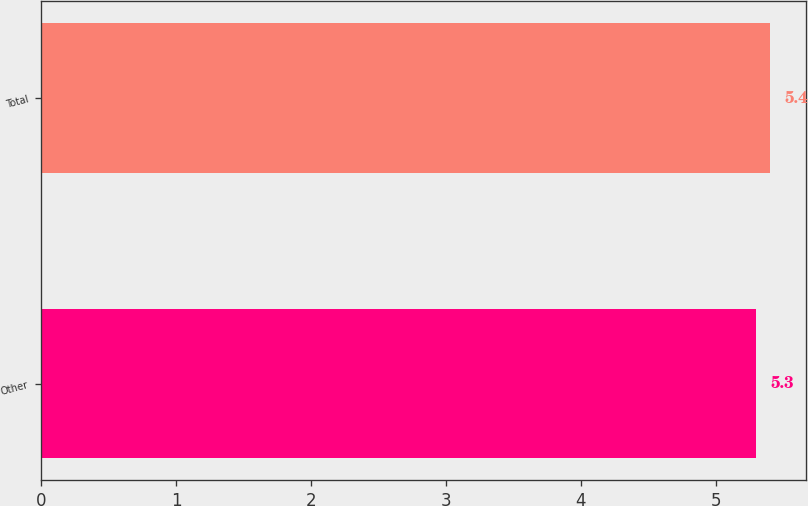Convert chart to OTSL. <chart><loc_0><loc_0><loc_500><loc_500><bar_chart><fcel>Other<fcel>Total<nl><fcel>5.3<fcel>5.4<nl></chart> 